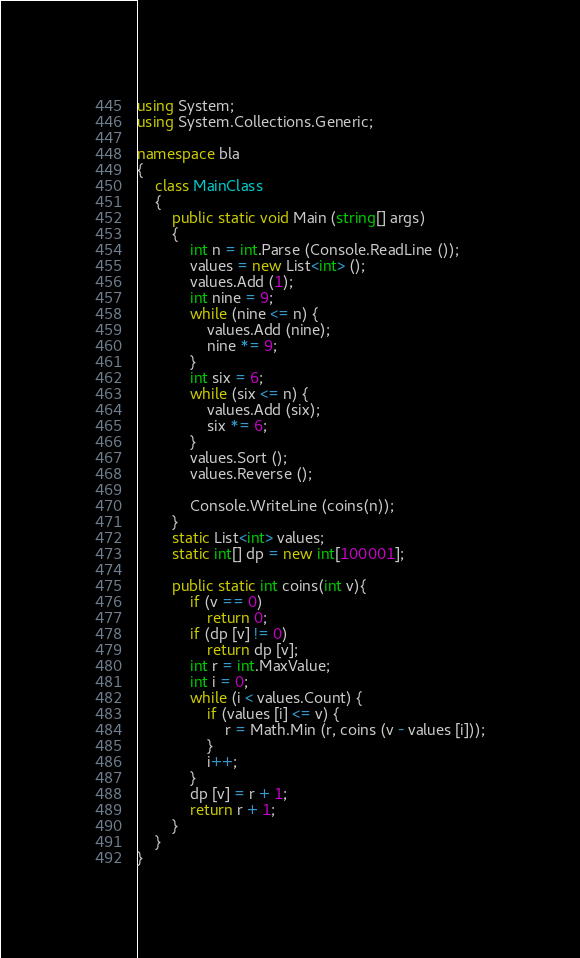<code> <loc_0><loc_0><loc_500><loc_500><_C#_>using System;
using System.Collections.Generic;

namespace bla
{
	class MainClass
	{
		public static void Main (string[] args)
		{
			int n = int.Parse (Console.ReadLine ());
			values = new List<int> ();
			values.Add (1);
			int nine = 9;
			while (nine <= n) {
				values.Add (nine);
				nine *= 9;
			}
			int six = 6;
			while (six <= n) {
				values.Add (six);
				six *= 6;
			}
			values.Sort ();
			values.Reverse ();

			Console.WriteLine (coins(n));
		}
		static List<int> values;
		static int[] dp = new int[100001];

		public static int coins(int v){
			if (v == 0)
				return 0;
			if (dp [v] != 0)
				return dp [v];
			int r = int.MaxValue;
			int i = 0;
			while (i < values.Count) {
				if (values [i] <= v) {
					r = Math.Min (r, coins (v - values [i]));
				}
				i++;
			}
			dp [v] = r + 1;
			return r + 1;
		}
	}
}
</code> 